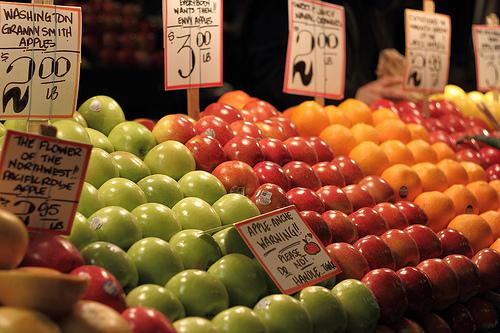Question: how many different types of apples are there?
Choices:
A. Six.
B. Two.
C. Four.
D. Three.
Answer with the letter. Answer: D Question: what color fruit is past the apples?
Choices:
A. Bananas.
B. Kiwi.
C. Oranges.
D. Strawberries.
Answer with the letter. Answer: C Question: what are the price signs attached to?
Choices:
A. Trees.
B. Boxes.
C. Wooden sticks.
D. Tables.
Answer with the letter. Answer: C Question: what words are above warning?
Choices:
A. High voltage.
B. APPLE-ANCHE.
C. Unstable.
D. Danger.
Answer with the letter. Answer: B 